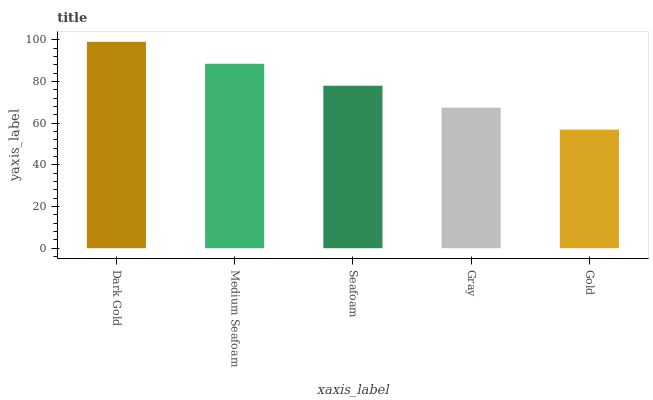Is Medium Seafoam the minimum?
Answer yes or no. No. Is Medium Seafoam the maximum?
Answer yes or no. No. Is Dark Gold greater than Medium Seafoam?
Answer yes or no. Yes. Is Medium Seafoam less than Dark Gold?
Answer yes or no. Yes. Is Medium Seafoam greater than Dark Gold?
Answer yes or no. No. Is Dark Gold less than Medium Seafoam?
Answer yes or no. No. Is Seafoam the high median?
Answer yes or no. Yes. Is Seafoam the low median?
Answer yes or no. Yes. Is Medium Seafoam the high median?
Answer yes or no. No. Is Medium Seafoam the low median?
Answer yes or no. No. 